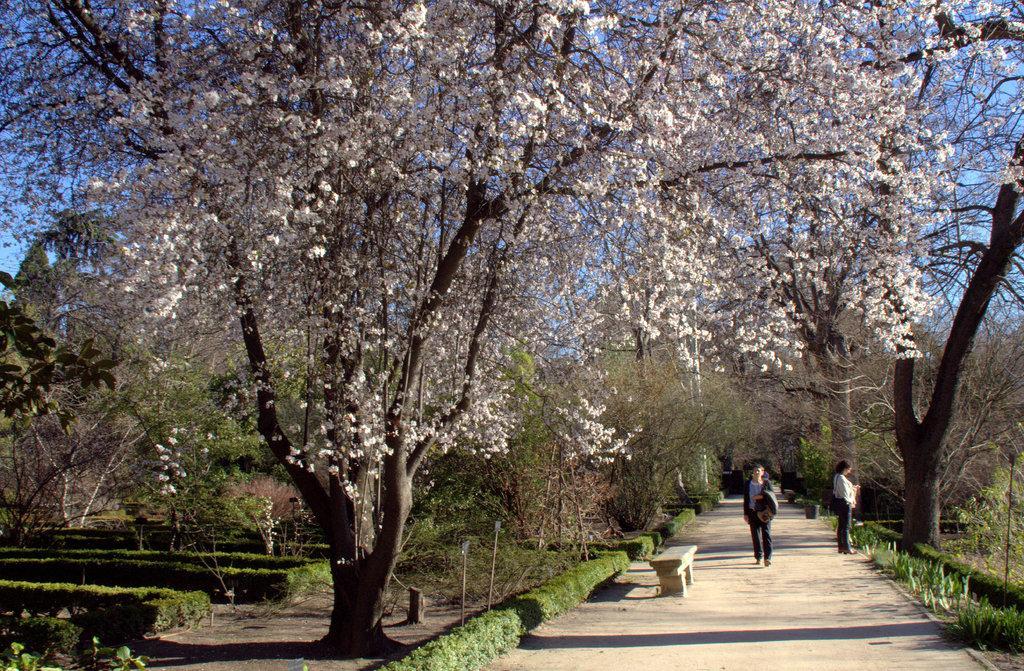How would you summarize this image in a sentence or two? In this picture there are people and a bench at the bottom side of the image and there is a flower tree on the left side of the image and there are other trees in the background area of the image. 